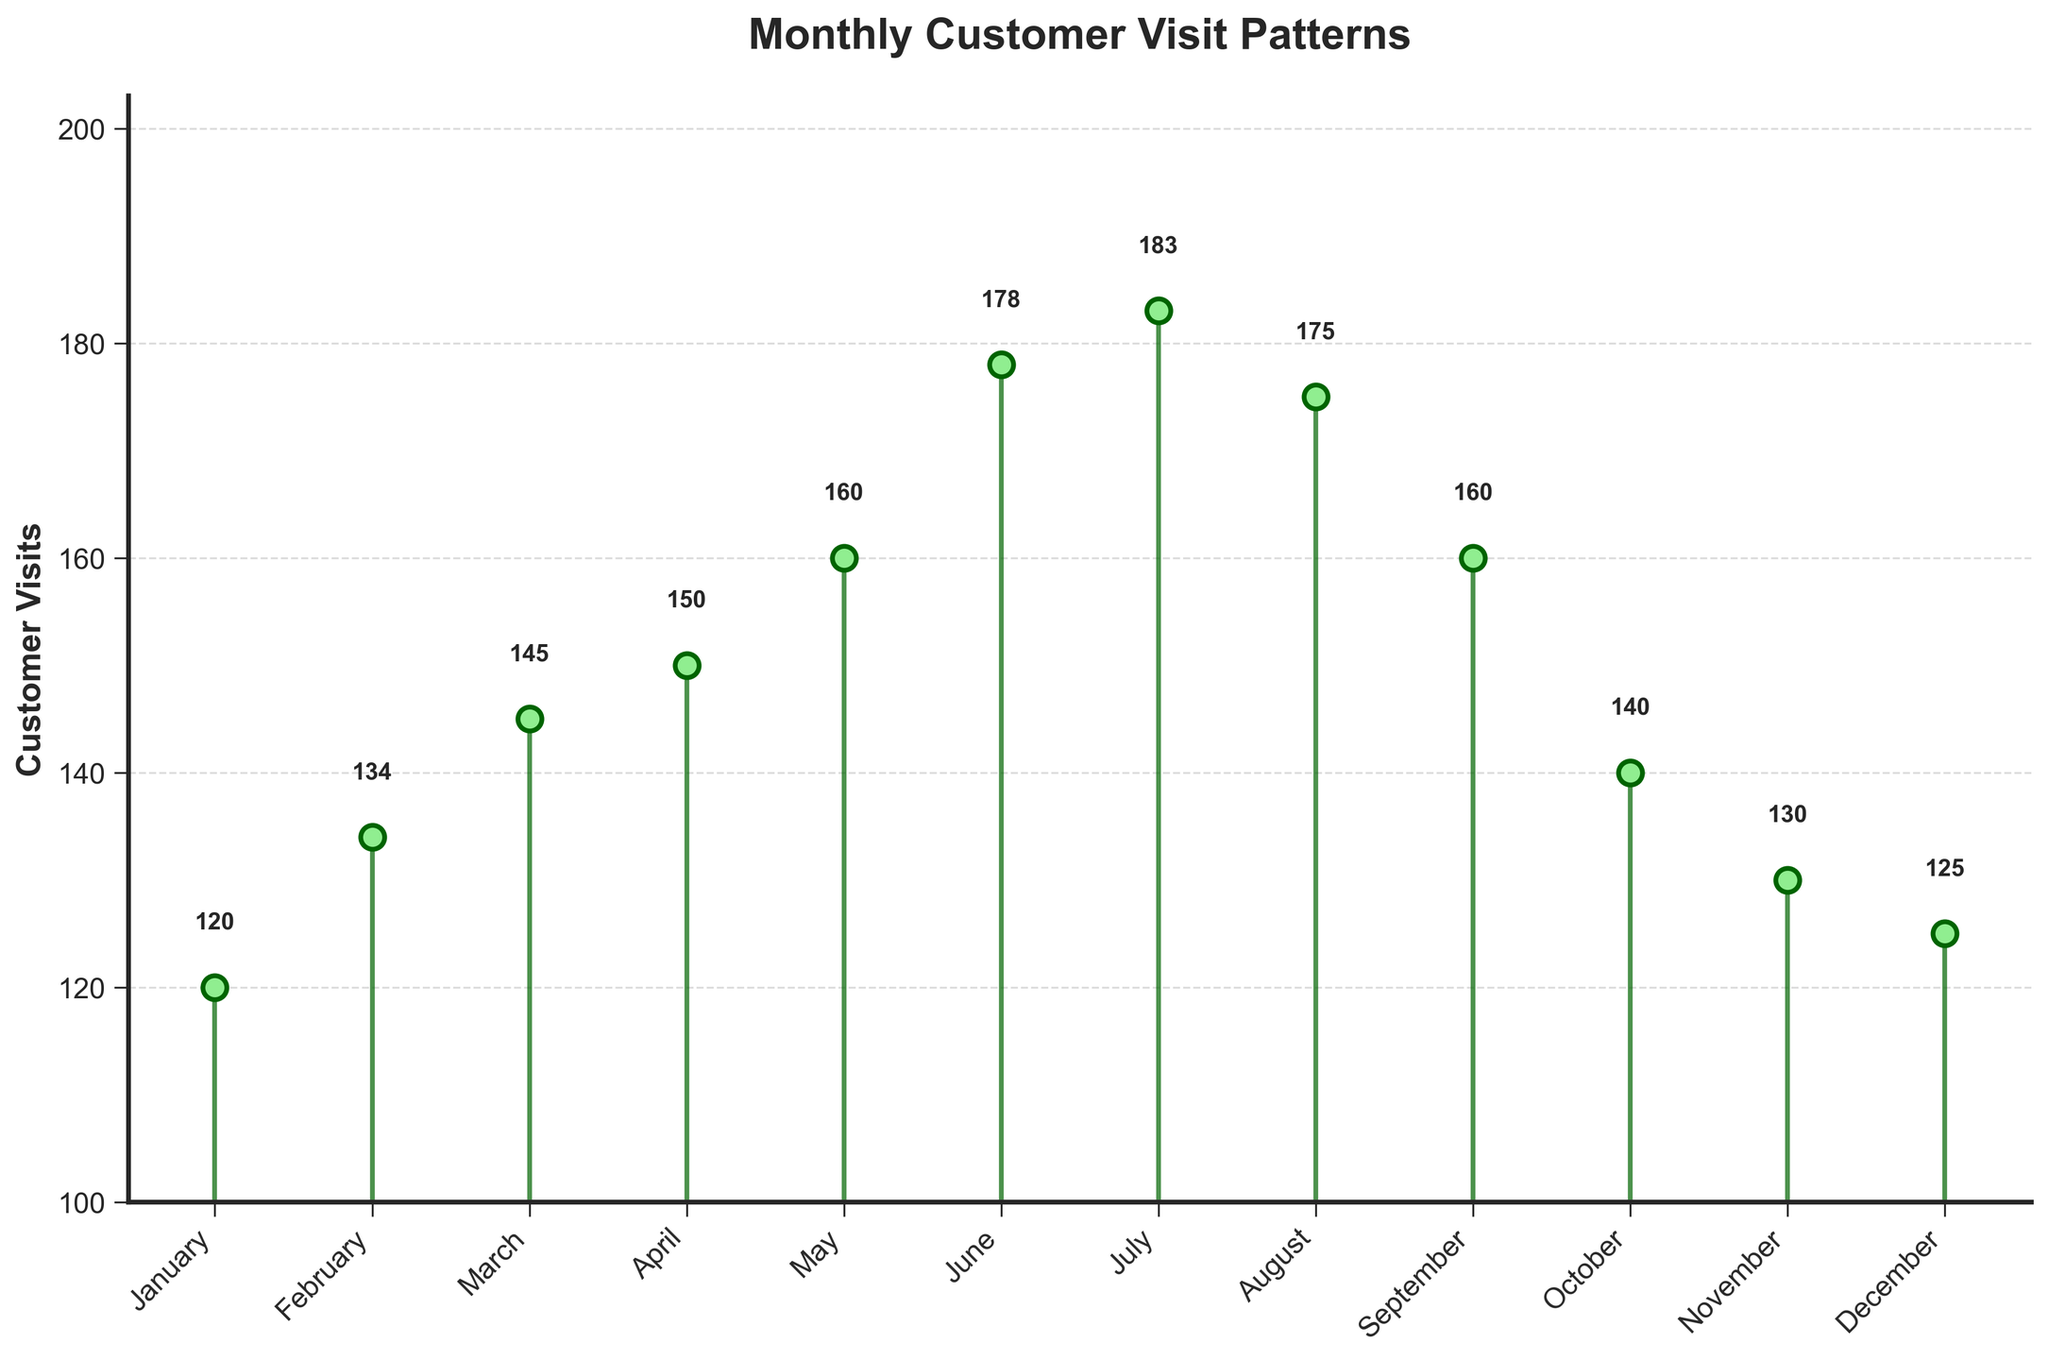What's the title of the figure? Look at the top of the plot where the title is displayed in bold text.
Answer: Monthly Customer Visit Patterns What is the minimum value of customer visits and in which month does it occur? Identify the lowest point in the stem plot and read the corresponding month and value from the x-axis and y-axis, respectively.
Answer: January, 120 What is the maximum value of customer visits and in which month does it occur? Identify the highest point in the stem plot and read the corresponding month and value from the x-axis and y-axis, respectively.
Answer: July, 183 What's the total number of customer visits from January to December? Sum all the customer visit values: 120 + 134 + 145 + 150 + 160 + 178 + 183 + 175 + 160 + 140 + 130 + 125.
Answer: 1,800 What is the average number of customer visits per month? Sum all the customer visit values and divide by 12: (120 + 134 + 145 + 150 + 160 + 178 + 183 + 175 + 160 + 140 + 130 + 125)/12.
Answer: 150 Which two consecutive months have the largest increase in customer visits? Calculate the differences between consecutive months and identify the maximum: February to March (145 - 134 = 11), April to May (160 - 150 = 10), etc.
Answer: June to July In which month(s) does the number of customer visits fall below 130? Identify the month(s) with customer visits less than 130: January (120), November (130 does not count as below).
Answer: January How many months have customer visits greater than the average monthly visits? Find the average (150) and count the months with values greater than 150: June (178), July (183), August (175), September (160), May (160).
Answer: 5 Compare the customer visits in June and July. In which month were the visits higher? Look at the stem plot points for June (178) and July (183); July has higher visits.
Answer: July How many times did the number of customer visits increase from one month to the next? Compare customer visits month by month and count the number of increases: February, March, April, May, June, July.
Answer: 6 